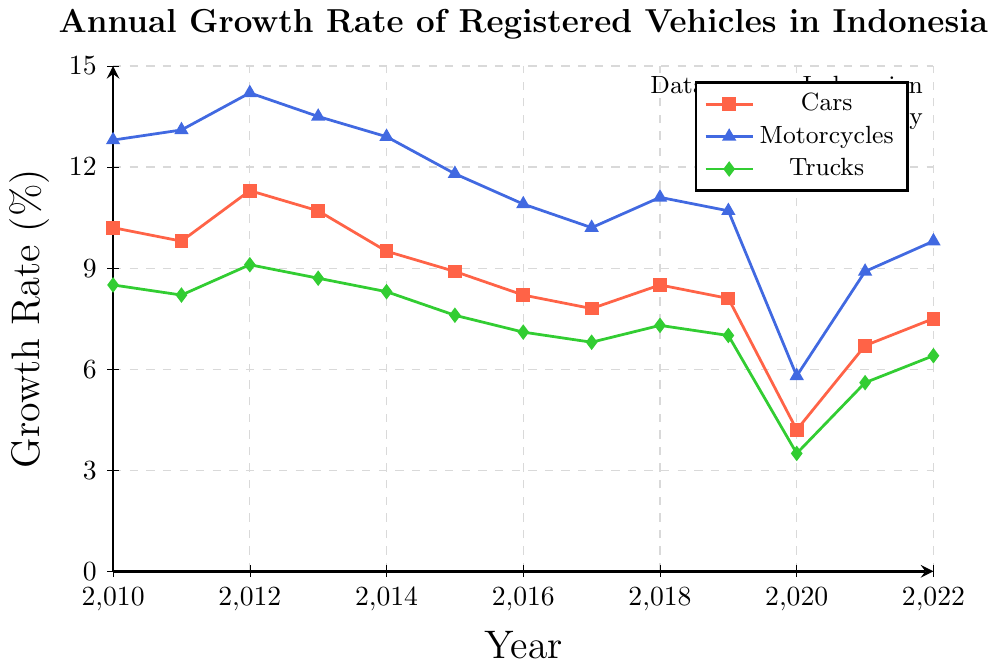What was the growth rate of registered motorcycles in 2012? By looking at the line chart, locate the year 2012 on the x-axis and trace it vertically until you reach the motorcycle line (blue). Read the y-axis value where the point is located.
Answer: 14.2% Which vehicle type had the lowest growth rate in 2020? Identify the three different lines representing cars (red), motorcycles (blue), and trucks (green) for the year 2020 on the x-axis. Compare the y-axis values of these points. The truck line has the lowest growth rate.
Answer: Trucks Between 2010 and 2022, in which year did cars see the highest growth rate? Examine the red line representing cars and identify the peak value. This peak occurs at the highest point on the y-axis. The highest point is in 2012.
Answer: 2012 Compare the growth rate of registered vehicles across all types in 2021. Which type had the highest growth rate? Find the points for all three vehicle types at the year 2021 on the x-axis. Compare their y-axis values and identify which one is the highest.
Answer: Motorcycles What is the average growth rate of registered trucks from 2010 to 2012? Add the growth rates of trucks for the years 2010, 2011, and 2012 (8.5 + 8.2 + 9.1) and divide by 3 to get the average.
Answer: 8.6% By how much did the growth rate of registered cars decrease from 2010 to 2017? Subtract the growth rate of cars in 2017 from that in 2010 (10.2 - 7.8).
Answer: 2.4% Which year saw the largest difference in growth rates between cars and motorcycles? For each year, calculate the absolute difference between the growth rates of cars and motorcycles. Identify the year with the largest difference.
Answer: 2020 What trend is observed in the growth rates of motorcycles from 2010 to 2016? Inspect the blue line across these years and describe the visual trend. The line shows a general decreasing trend.
Answer: Decreasing From 2010 to 2022, how many years did the growth rate of trucks fall below 7%? Count the number of years where the green line falls below the 7% mark on the y-axis. The years are 2016, 2017, 2020, and 2021.
Answer: 4 Estimate the difference in growth rates between motorcycles and trucks in 2018. Locate the points for motorcycles and trucks for 2018. Subtract the truck's growth rate from the motorcycle's growth rate (11.1 - 7.3).
Answer: 3.8% 